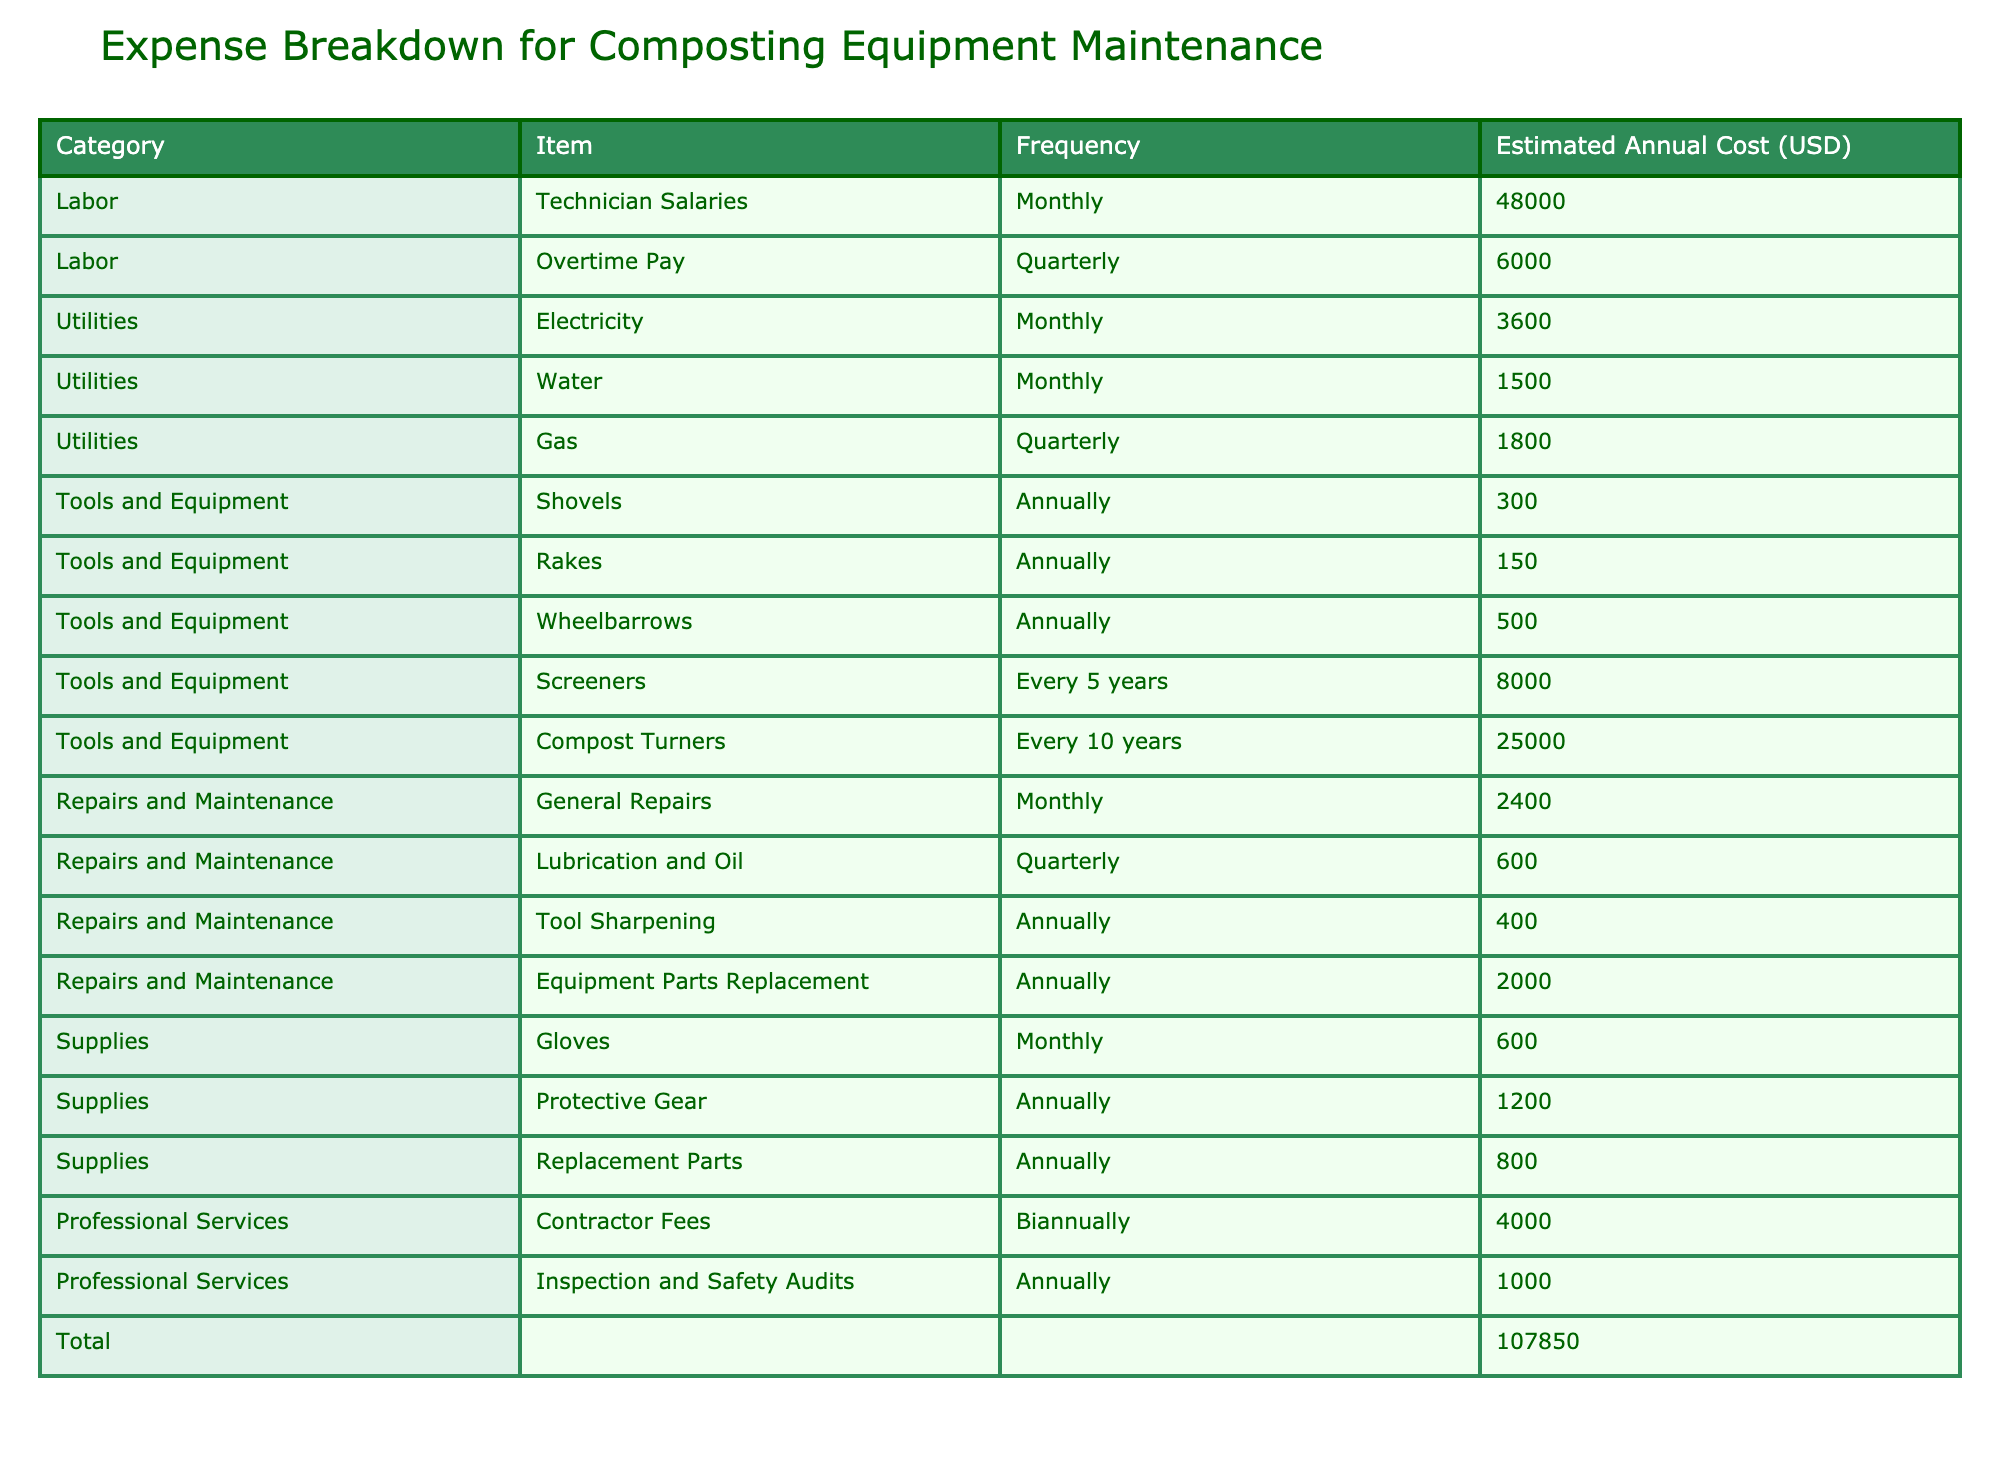What is the total estimated annual cost for composting equipment maintenance? To find the total estimated annual cost, we need to look at the last row in the table. It shows that the total for all categories is 66300 USD.
Answer: 66300 USD How much does the facility spend annually on utilities? The table lists three utility items: Electricity (3600), Water (1500), and Gas (calculated as annual from quarterly, which is 1800/4 = 4500). Adding these together gives us 3600 + 1500 + 7200 = 12300 USD.
Answer: 12300 USD Is the cost of compost turners listed as annual or longer? The costs for compost turners are listed with a frequency of every 10 years, confirming that it is not an annual expense.
Answer: No What are the total costs for tools and equipment? To calculate the total costs for tools and equipment, we sum the values: Shovels (300), Rakes (150), Wheelbarrows (500), Screeners (8000 divided by 5 to get the annual cost = 1600), and Compost Turners (25000 divided by 10 to get the annual cost = 2500). The total is 300 + 150 + 500 + 1600 + 2500 = 5050 USD.
Answer: 5050 USD How often is lubrication and oil maintenance paid for? The table indicates that lubrication and oil maintenance is paid for quarterly, as specified in its frequency column.
Answer: Quarterly 